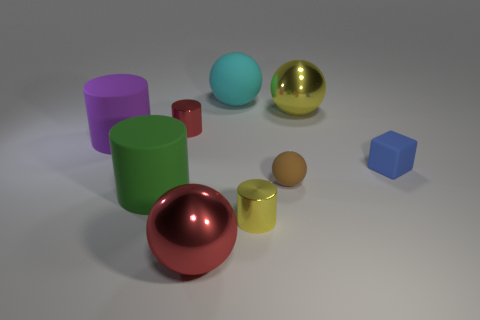Subtract all red cylinders. How many cylinders are left? 3 Add 1 big red cylinders. How many objects exist? 10 Subtract all cyan balls. How many balls are left? 3 Add 2 cyan objects. How many cyan objects are left? 3 Add 4 big red spheres. How many big red spheres exist? 5 Subtract 0 green blocks. How many objects are left? 9 Subtract all cylinders. How many objects are left? 5 Subtract 2 balls. How many balls are left? 2 Subtract all red cubes. Subtract all red spheres. How many cubes are left? 1 Subtract all green cylinders. How many gray spheres are left? 0 